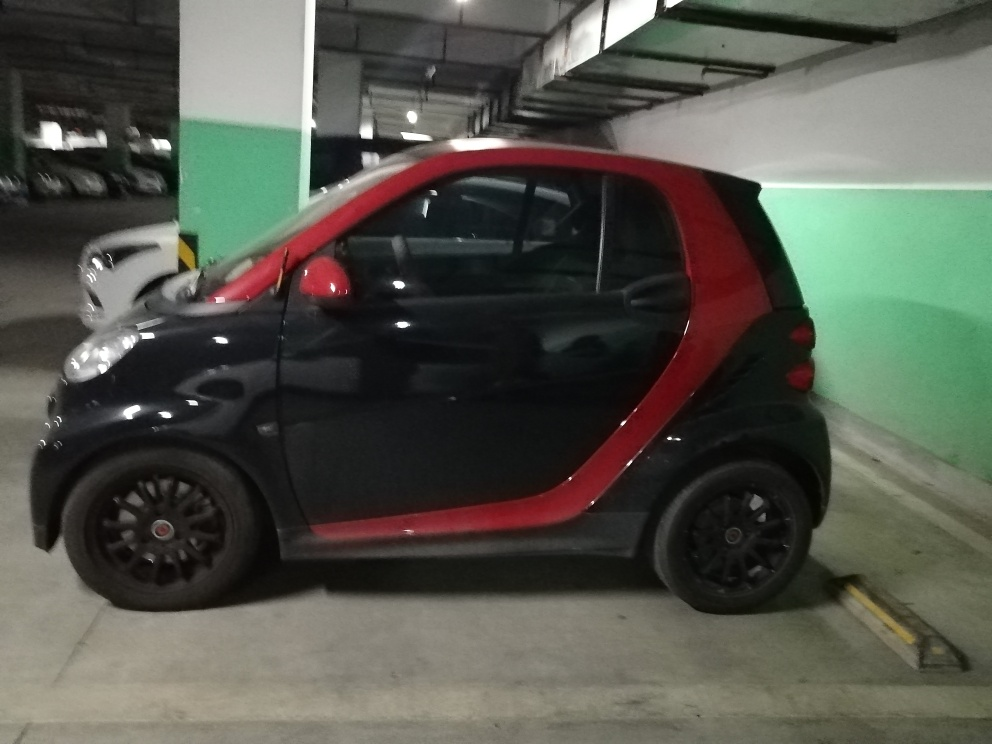Does the car look well-maintained? From this angle and lighting condition, the car's exterior appears to be in good condition, with no visible dents or scratches. The paint seems consistent and glossy, which usually indicates regular cleaning and maintenance. Given its size, what are the advantages of this type of car in city settings? In urban settings, this type of compact car offers numerous advantages: its smaller size makes it easier to maneuver through narrow streets and in tight traffic. Parking is more convenient, as it requires less space, which is a significant benefit in crowded city centers where parking can be scarce. Additionally, such cars often have better fuel efficiency and lower emissions, making them more eco-friendly and economical for city living. 